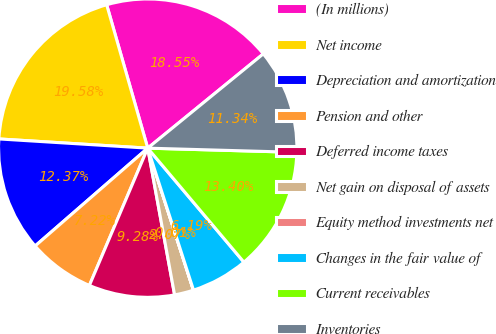Convert chart to OTSL. <chart><loc_0><loc_0><loc_500><loc_500><pie_chart><fcel>(In millions)<fcel>Net income<fcel>Depreciation and amortization<fcel>Pension and other<fcel>Deferred income taxes<fcel>Net gain on disposal of assets<fcel>Equity method investments net<fcel>Changes in the fair value of<fcel>Current receivables<fcel>Inventories<nl><fcel>18.55%<fcel>19.58%<fcel>12.37%<fcel>7.22%<fcel>9.28%<fcel>2.07%<fcel>0.01%<fcel>6.19%<fcel>13.4%<fcel>11.34%<nl></chart> 